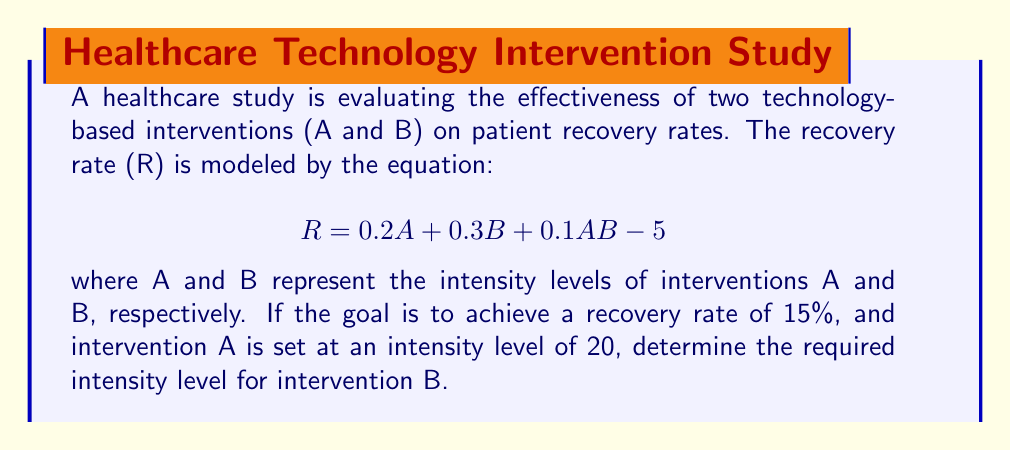Teach me how to tackle this problem. To solve this problem, we'll follow these steps:

1) We're given the equation for the recovery rate (R):
   $$R = 0.2A + 0.3B + 0.1AB - 5$$

2) We know that:
   - The target recovery rate (R) is 15%
   - The intensity level of intervention A (A) is 20

3) Let's substitute these known values into the equation:
   $$15 = 0.2(20) + 0.3B + 0.1(20)B - 5$$

4) Simplify the known terms:
   $$15 = 4 + 0.3B + 2B - 5$$
   $$15 = -1 + 0.3B + 2B$$

5) Combine like terms:
   $$15 = -1 + 2.3B$$

6) Add 1 to both sides:
   $$16 = 2.3B$$

7) Divide both sides by 2.3:
   $$\frac{16}{2.3} = B$$

8) Calculate the final value:
   $$B \approx 6.96$$

Since intensity levels are typically whole numbers, we round up to the nearest integer.
Answer: 7 